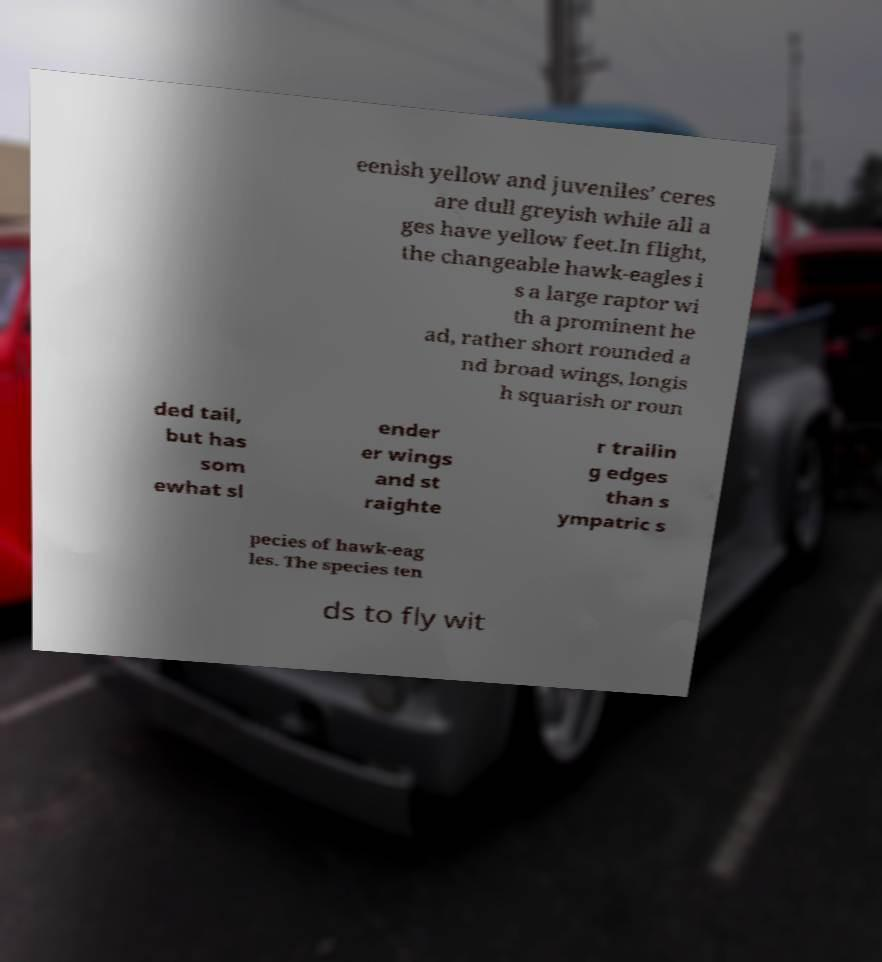Could you extract and type out the text from this image? eenish yellow and juveniles’ ceres are dull greyish while all a ges have yellow feet.In flight, the changeable hawk-eagles i s a large raptor wi th a prominent he ad, rather short rounded a nd broad wings, longis h squarish or roun ded tail, but has som ewhat sl ender er wings and st raighte r trailin g edges than s ympatric s pecies of hawk-eag les. The species ten ds to fly wit 